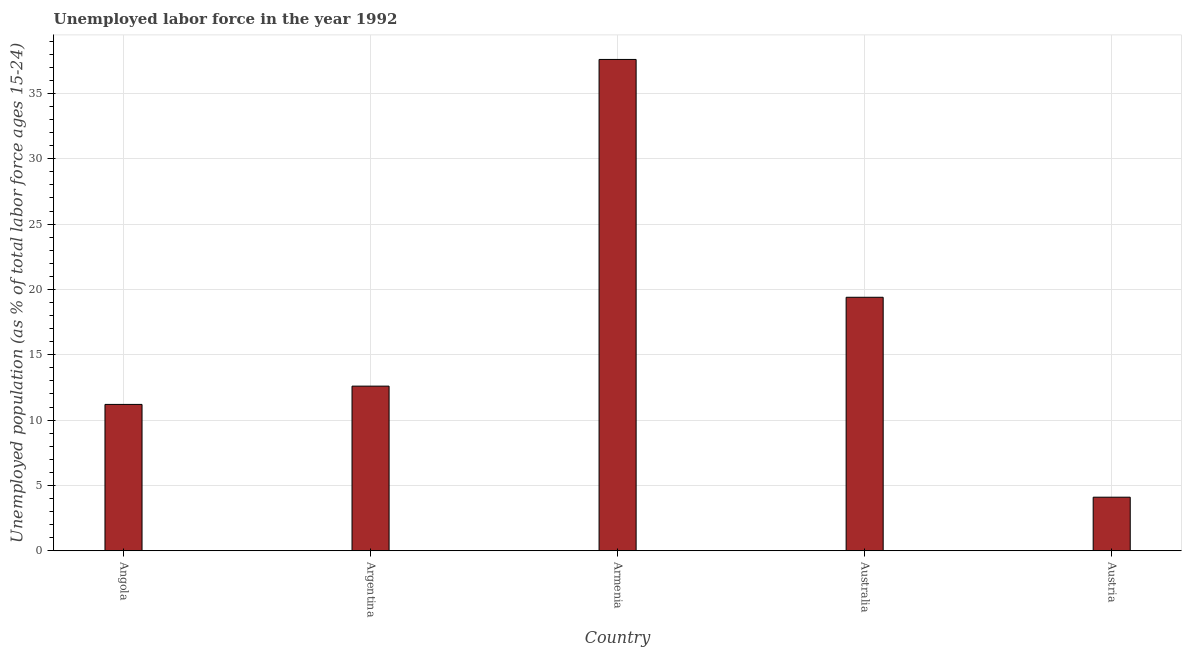Does the graph contain any zero values?
Provide a short and direct response. No. Does the graph contain grids?
Offer a very short reply. Yes. What is the title of the graph?
Your answer should be compact. Unemployed labor force in the year 1992. What is the label or title of the X-axis?
Ensure brevity in your answer.  Country. What is the label or title of the Y-axis?
Give a very brief answer. Unemployed population (as % of total labor force ages 15-24). What is the total unemployed youth population in Armenia?
Provide a short and direct response. 37.6. Across all countries, what is the maximum total unemployed youth population?
Offer a very short reply. 37.6. Across all countries, what is the minimum total unemployed youth population?
Offer a very short reply. 4.1. In which country was the total unemployed youth population maximum?
Your answer should be very brief. Armenia. What is the sum of the total unemployed youth population?
Provide a short and direct response. 84.9. What is the difference between the total unemployed youth population in Armenia and Australia?
Provide a short and direct response. 18.2. What is the average total unemployed youth population per country?
Your response must be concise. 16.98. What is the median total unemployed youth population?
Your answer should be compact. 12.6. What is the ratio of the total unemployed youth population in Argentina to that in Armenia?
Your response must be concise. 0.34. Is the total unemployed youth population in Argentina less than that in Austria?
Ensure brevity in your answer.  No. Is the difference between the total unemployed youth population in Argentina and Austria greater than the difference between any two countries?
Give a very brief answer. No. Is the sum of the total unemployed youth population in Angola and Australia greater than the maximum total unemployed youth population across all countries?
Provide a short and direct response. No. What is the difference between the highest and the lowest total unemployed youth population?
Make the answer very short. 33.5. How many countries are there in the graph?
Ensure brevity in your answer.  5. What is the Unemployed population (as % of total labor force ages 15-24) of Angola?
Provide a short and direct response. 11.2. What is the Unemployed population (as % of total labor force ages 15-24) in Argentina?
Provide a succinct answer. 12.6. What is the Unemployed population (as % of total labor force ages 15-24) in Armenia?
Offer a terse response. 37.6. What is the Unemployed population (as % of total labor force ages 15-24) of Australia?
Offer a very short reply. 19.4. What is the Unemployed population (as % of total labor force ages 15-24) of Austria?
Offer a terse response. 4.1. What is the difference between the Unemployed population (as % of total labor force ages 15-24) in Angola and Argentina?
Your answer should be very brief. -1.4. What is the difference between the Unemployed population (as % of total labor force ages 15-24) in Angola and Armenia?
Provide a short and direct response. -26.4. What is the difference between the Unemployed population (as % of total labor force ages 15-24) in Argentina and Armenia?
Make the answer very short. -25. What is the difference between the Unemployed population (as % of total labor force ages 15-24) in Argentina and Australia?
Provide a succinct answer. -6.8. What is the difference between the Unemployed population (as % of total labor force ages 15-24) in Argentina and Austria?
Offer a very short reply. 8.5. What is the difference between the Unemployed population (as % of total labor force ages 15-24) in Armenia and Austria?
Your answer should be compact. 33.5. What is the ratio of the Unemployed population (as % of total labor force ages 15-24) in Angola to that in Argentina?
Give a very brief answer. 0.89. What is the ratio of the Unemployed population (as % of total labor force ages 15-24) in Angola to that in Armenia?
Give a very brief answer. 0.3. What is the ratio of the Unemployed population (as % of total labor force ages 15-24) in Angola to that in Australia?
Offer a terse response. 0.58. What is the ratio of the Unemployed population (as % of total labor force ages 15-24) in Angola to that in Austria?
Offer a very short reply. 2.73. What is the ratio of the Unemployed population (as % of total labor force ages 15-24) in Argentina to that in Armenia?
Provide a succinct answer. 0.34. What is the ratio of the Unemployed population (as % of total labor force ages 15-24) in Argentina to that in Australia?
Your answer should be compact. 0.65. What is the ratio of the Unemployed population (as % of total labor force ages 15-24) in Argentina to that in Austria?
Provide a short and direct response. 3.07. What is the ratio of the Unemployed population (as % of total labor force ages 15-24) in Armenia to that in Australia?
Your answer should be compact. 1.94. What is the ratio of the Unemployed population (as % of total labor force ages 15-24) in Armenia to that in Austria?
Provide a succinct answer. 9.17. What is the ratio of the Unemployed population (as % of total labor force ages 15-24) in Australia to that in Austria?
Provide a succinct answer. 4.73. 